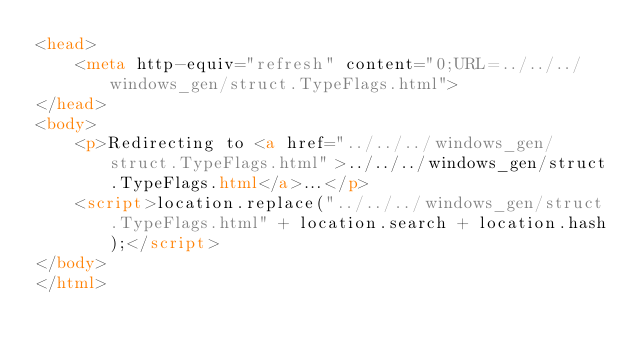Convert code to text. <code><loc_0><loc_0><loc_500><loc_500><_HTML_><head>
    <meta http-equiv="refresh" content="0;URL=../../../windows_gen/struct.TypeFlags.html">
</head>
<body>
    <p>Redirecting to <a href="../../../windows_gen/struct.TypeFlags.html">../../../windows_gen/struct.TypeFlags.html</a>...</p>
    <script>location.replace("../../../windows_gen/struct.TypeFlags.html" + location.search + location.hash);</script>
</body>
</html></code> 